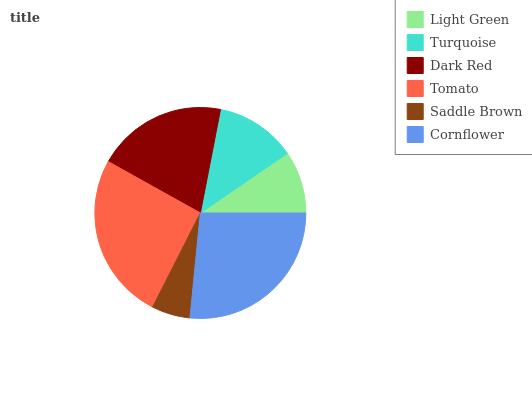Is Saddle Brown the minimum?
Answer yes or no. Yes. Is Cornflower the maximum?
Answer yes or no. Yes. Is Turquoise the minimum?
Answer yes or no. No. Is Turquoise the maximum?
Answer yes or no. No. Is Turquoise greater than Light Green?
Answer yes or no. Yes. Is Light Green less than Turquoise?
Answer yes or no. Yes. Is Light Green greater than Turquoise?
Answer yes or no. No. Is Turquoise less than Light Green?
Answer yes or no. No. Is Dark Red the high median?
Answer yes or no. Yes. Is Turquoise the low median?
Answer yes or no. Yes. Is Turquoise the high median?
Answer yes or no. No. Is Dark Red the low median?
Answer yes or no. No. 